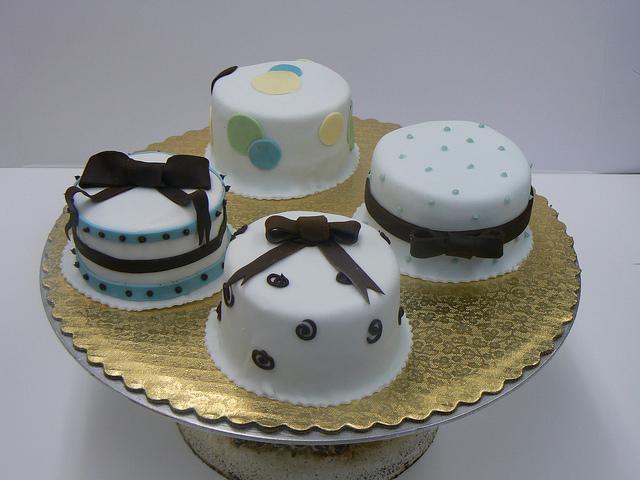What event are these pastries made for?
Be succinct. Wedding. How many cakes are on the table?
Give a very brief answer. 4. How many layers in the cake?
Write a very short answer. 2. What type of food is this?
Answer briefly. Cake. What is on the plate?
Give a very brief answer. Cakes. 